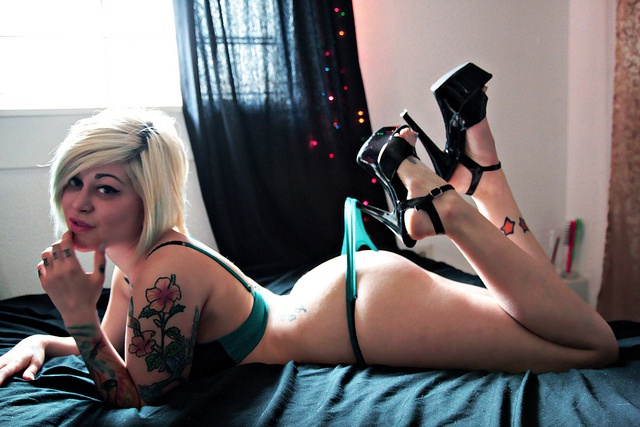Describe the objects in this image and their specific colors. I can see people in white, black, and brown tones and bed in white, black, teal, and blue tones in this image. 